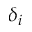<formula> <loc_0><loc_0><loc_500><loc_500>\delta _ { i }</formula> 